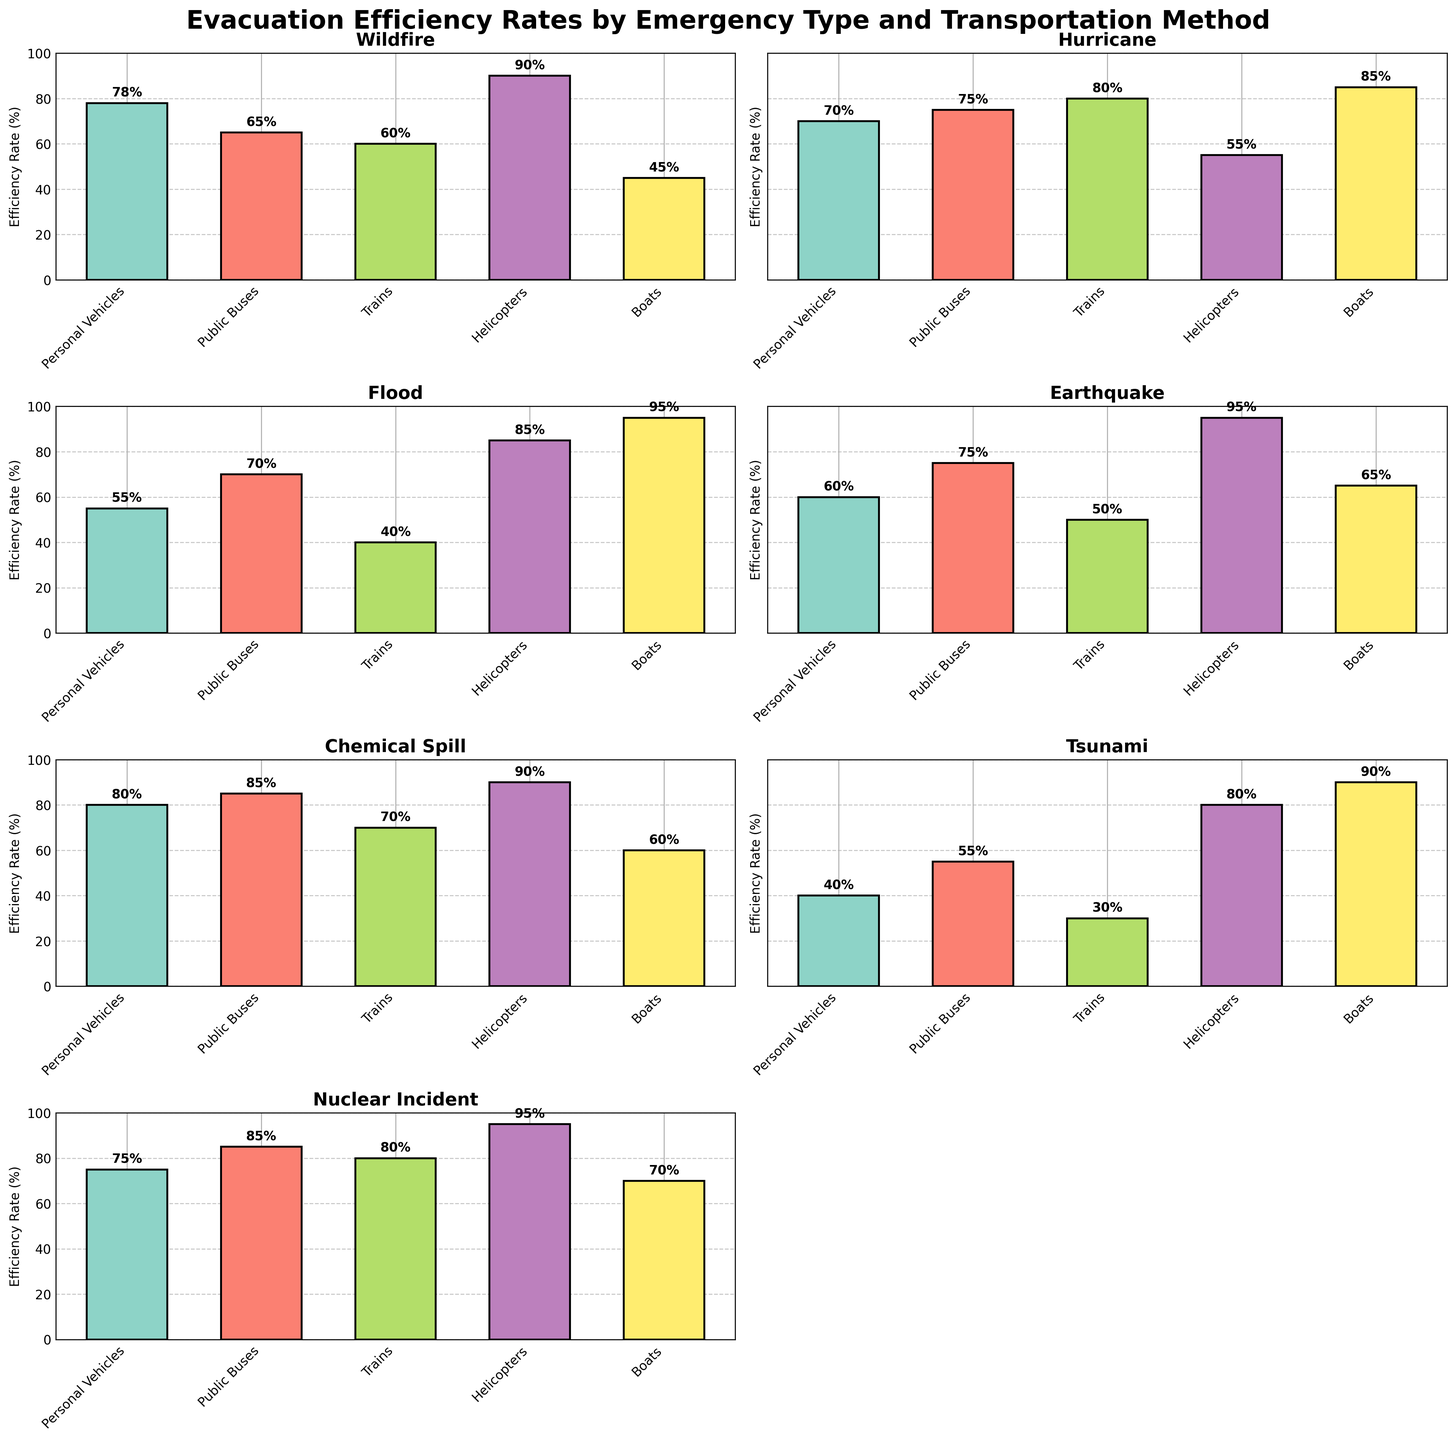How does the evacuation efficiency rate of helicopters compare across different emergency types? To compare the evacuation efficiency rate of helicopters, look at the height of the helicopter bars in each subplot. Observe that Wildfire has 90%, Hurricane has 55%, Flood has 85%, Earthquake has 95%, Chemical Spill has 90%, Tsunami has 80%, and Nuclear Incident has 95%.
Answer: Earthquake and Nuclear Incident are the highest at 95% Which transportation method has the highest evacuation efficiency rate during a flood? Look at the bars in the Flood subplot and compare their heights. The boat bar is the tallest, indicating the highest evacuation efficiency rate during a flood.
Answer: Boats What's the average evacuation efficiency rate for public buses across all emergency types? Calculate the sum of the evacuation rates for public buses across all emergency types and divide by the number of emergency types. Sum: 65% (Wildfire) + 75% (Hurricane) + 70% (Flood) + 75% (Earthquake) + 85% (Chemical Spill) + 55% (Tsunami) + 85% (Nuclear Incident) = 510%. Divide by the number of emergency types (7). Average: 510% / 7 ≈ 72.86%
Answer: 72.86% Which emergency type has the lowest evacuation efficiency rate for trains, and what is that rate? Compare the train bars across all subplots. The shortest bar for trains is in the Tsunami subplot. The evacuation efficiency rate for trains during a tsunami is 30%.
Answer: Tsunami, 30% Sum the evacuation efficiency rates of personal vehicles and helicopters during a hurricane. Locate the Hurricane subplot and find the evacuation efficiency rates for personal vehicles and helicopters, which are 70% and 55%, respectively. Sum these rates: 70% + 55% = 125%
Answer: 125% Which transportation method has the most consistent evacuation efficiency rates across all emergency types? Look for the transportation method whose bars are the most similar in height across all subplots. Public buses have relatively consistent evacuation efficiency rates, ranging closely from 55% to 85%.
Answer: Public Buses Compare the evacuation efficiency rates of boats for a chemical spill and nuclear incident. Which is higher and by how much? Identify the boat bars for Chemical Spill and Nuclear Incident subplots. Chemical Spill has 60%, and Nuclear Incident has 70%. Subtract the rates: 70% - 60% = 10%.
Answer: Nuclear Incident by 10% Between personal vehicles and trains, which has a better evacuation efficiency rate during an earthquake? Look at the heights of the bars for personal vehicles and trains in the Earthquake subplot. Personal vehicles are at 60%, and trains are at 50%.
Answer: Personal Vehicles How much higher is the evacuation efficiency rate of helicopters compared to boats during a wildfire? Find the bars for helicopters and boats in the Wildfire subplot. Helicopters have 90%, and boats have 45%. Subtract the rates: 90% - 45% = 45%.
Answer: 45% What is the difference in evacuation efficiency rates between public buses and trains during a nuclear incident? In the Nuclear Incident subplot, find the efficiency rates for public buses and trains. Public buses are at 85%, and trains are at 80%. Subtract the rates: 85% - 80% = 5%.
Answer: 5% 